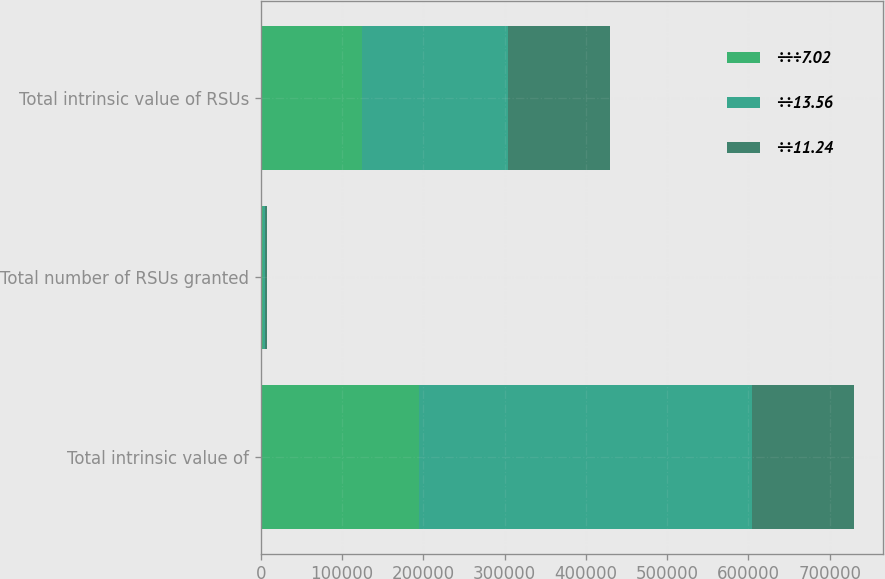Convert chart. <chart><loc_0><loc_0><loc_500><loc_500><stacked_bar_chart><ecel><fcel>Total intrinsic value of<fcel>Total number of RSUs granted<fcel>Total intrinsic value of RSUs<nl><fcel>÷÷÷7.02<fcel>194545<fcel>2653<fcel>124193<nl><fcel>÷÷13.56<fcel>410152<fcel>2135<fcel>180563<nl><fcel>÷÷11.24<fcel>124854<fcel>2342<fcel>125514<nl></chart> 